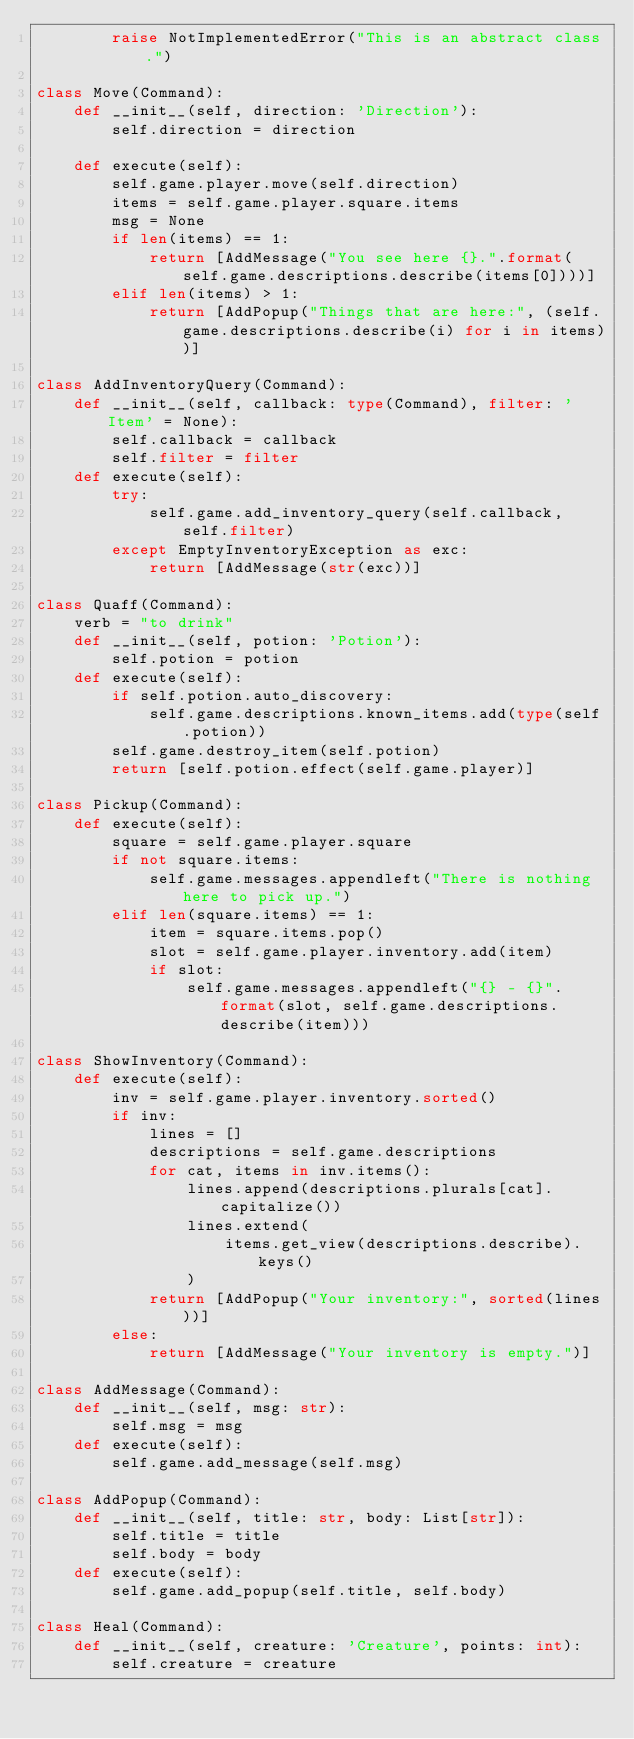<code> <loc_0><loc_0><loc_500><loc_500><_Python_>        raise NotImplementedError("This is an abstract class.")

class Move(Command):
    def __init__(self, direction: 'Direction'):
        self.direction = direction
 
    def execute(self):
        self.game.player.move(self.direction)
        items = self.game.player.square.items
        msg = None
        if len(items) == 1:
            return [AddMessage("You see here {}.".format(self.game.descriptions.describe(items[0])))]
        elif len(items) > 1:
            return [AddPopup("Things that are here:", (self.game.descriptions.describe(i) for i in items))]

class AddInventoryQuery(Command):
    def __init__(self, callback: type(Command), filter: 'Item' = None):
        self.callback = callback
        self.filter = filter
    def execute(self):
        try:
            self.game.add_inventory_query(self.callback, self.filter)
        except EmptyInventoryException as exc:
            return [AddMessage(str(exc))]

class Quaff(Command):
    verb = "to drink"
    def __init__(self, potion: 'Potion'):
        self.potion = potion
    def execute(self):
        if self.potion.auto_discovery:
            self.game.descriptions.known_items.add(type(self.potion))
        self.game.destroy_item(self.potion)
        return [self.potion.effect(self.game.player)]

class Pickup(Command):
    def execute(self):
        square = self.game.player.square
        if not square.items:
            self.game.messages.appendleft("There is nothing here to pick up.")
        elif len(square.items) == 1:
            item = square.items.pop()
            slot = self.game.player.inventory.add(item)
            if slot:
                self.game.messages.appendleft("{} - {}".format(slot, self.game.descriptions.describe(item)))

class ShowInventory(Command):
    def execute(self):
        inv = self.game.player.inventory.sorted()
        if inv:
            lines = []
            descriptions = self.game.descriptions
            for cat, items in inv.items():
                lines.append(descriptions.plurals[cat].capitalize())
                lines.extend(
                    items.get_view(descriptions.describe).keys()
                )
            return [AddPopup("Your inventory:", sorted(lines))]
        else:
            return [AddMessage("Your inventory is empty.")]

class AddMessage(Command):
    def __init__(self, msg: str):
        self.msg = msg
    def execute(self):
        self.game.add_message(self.msg)

class AddPopup(Command):
    def __init__(self, title: str, body: List[str]):
        self.title = title
        self.body = body
    def execute(self):
        self.game.add_popup(self.title, self.body)

class Heal(Command):
    def __init__(self, creature: 'Creature', points: int):
        self.creature = creature</code> 